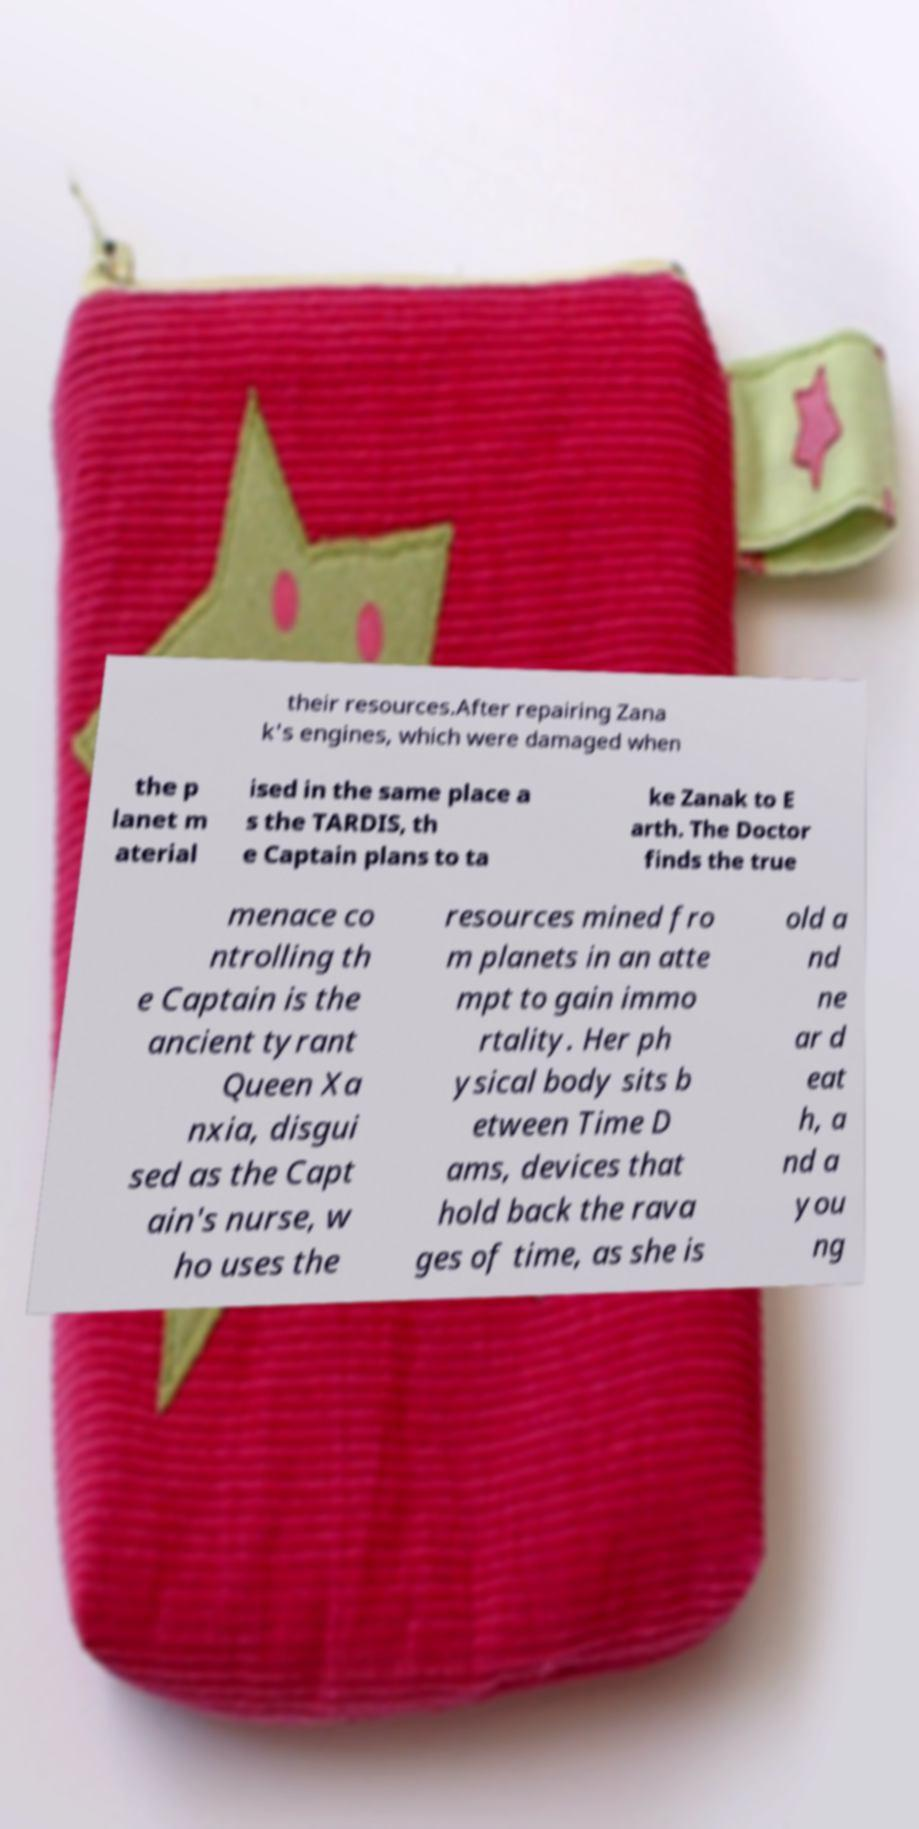Please read and relay the text visible in this image. What does it say? their resources.After repairing Zana k's engines, which were damaged when the p lanet m aterial ised in the same place a s the TARDIS, th e Captain plans to ta ke Zanak to E arth. The Doctor finds the true menace co ntrolling th e Captain is the ancient tyrant Queen Xa nxia, disgui sed as the Capt ain's nurse, w ho uses the resources mined fro m planets in an atte mpt to gain immo rtality. Her ph ysical body sits b etween Time D ams, devices that hold back the rava ges of time, as she is old a nd ne ar d eat h, a nd a you ng 